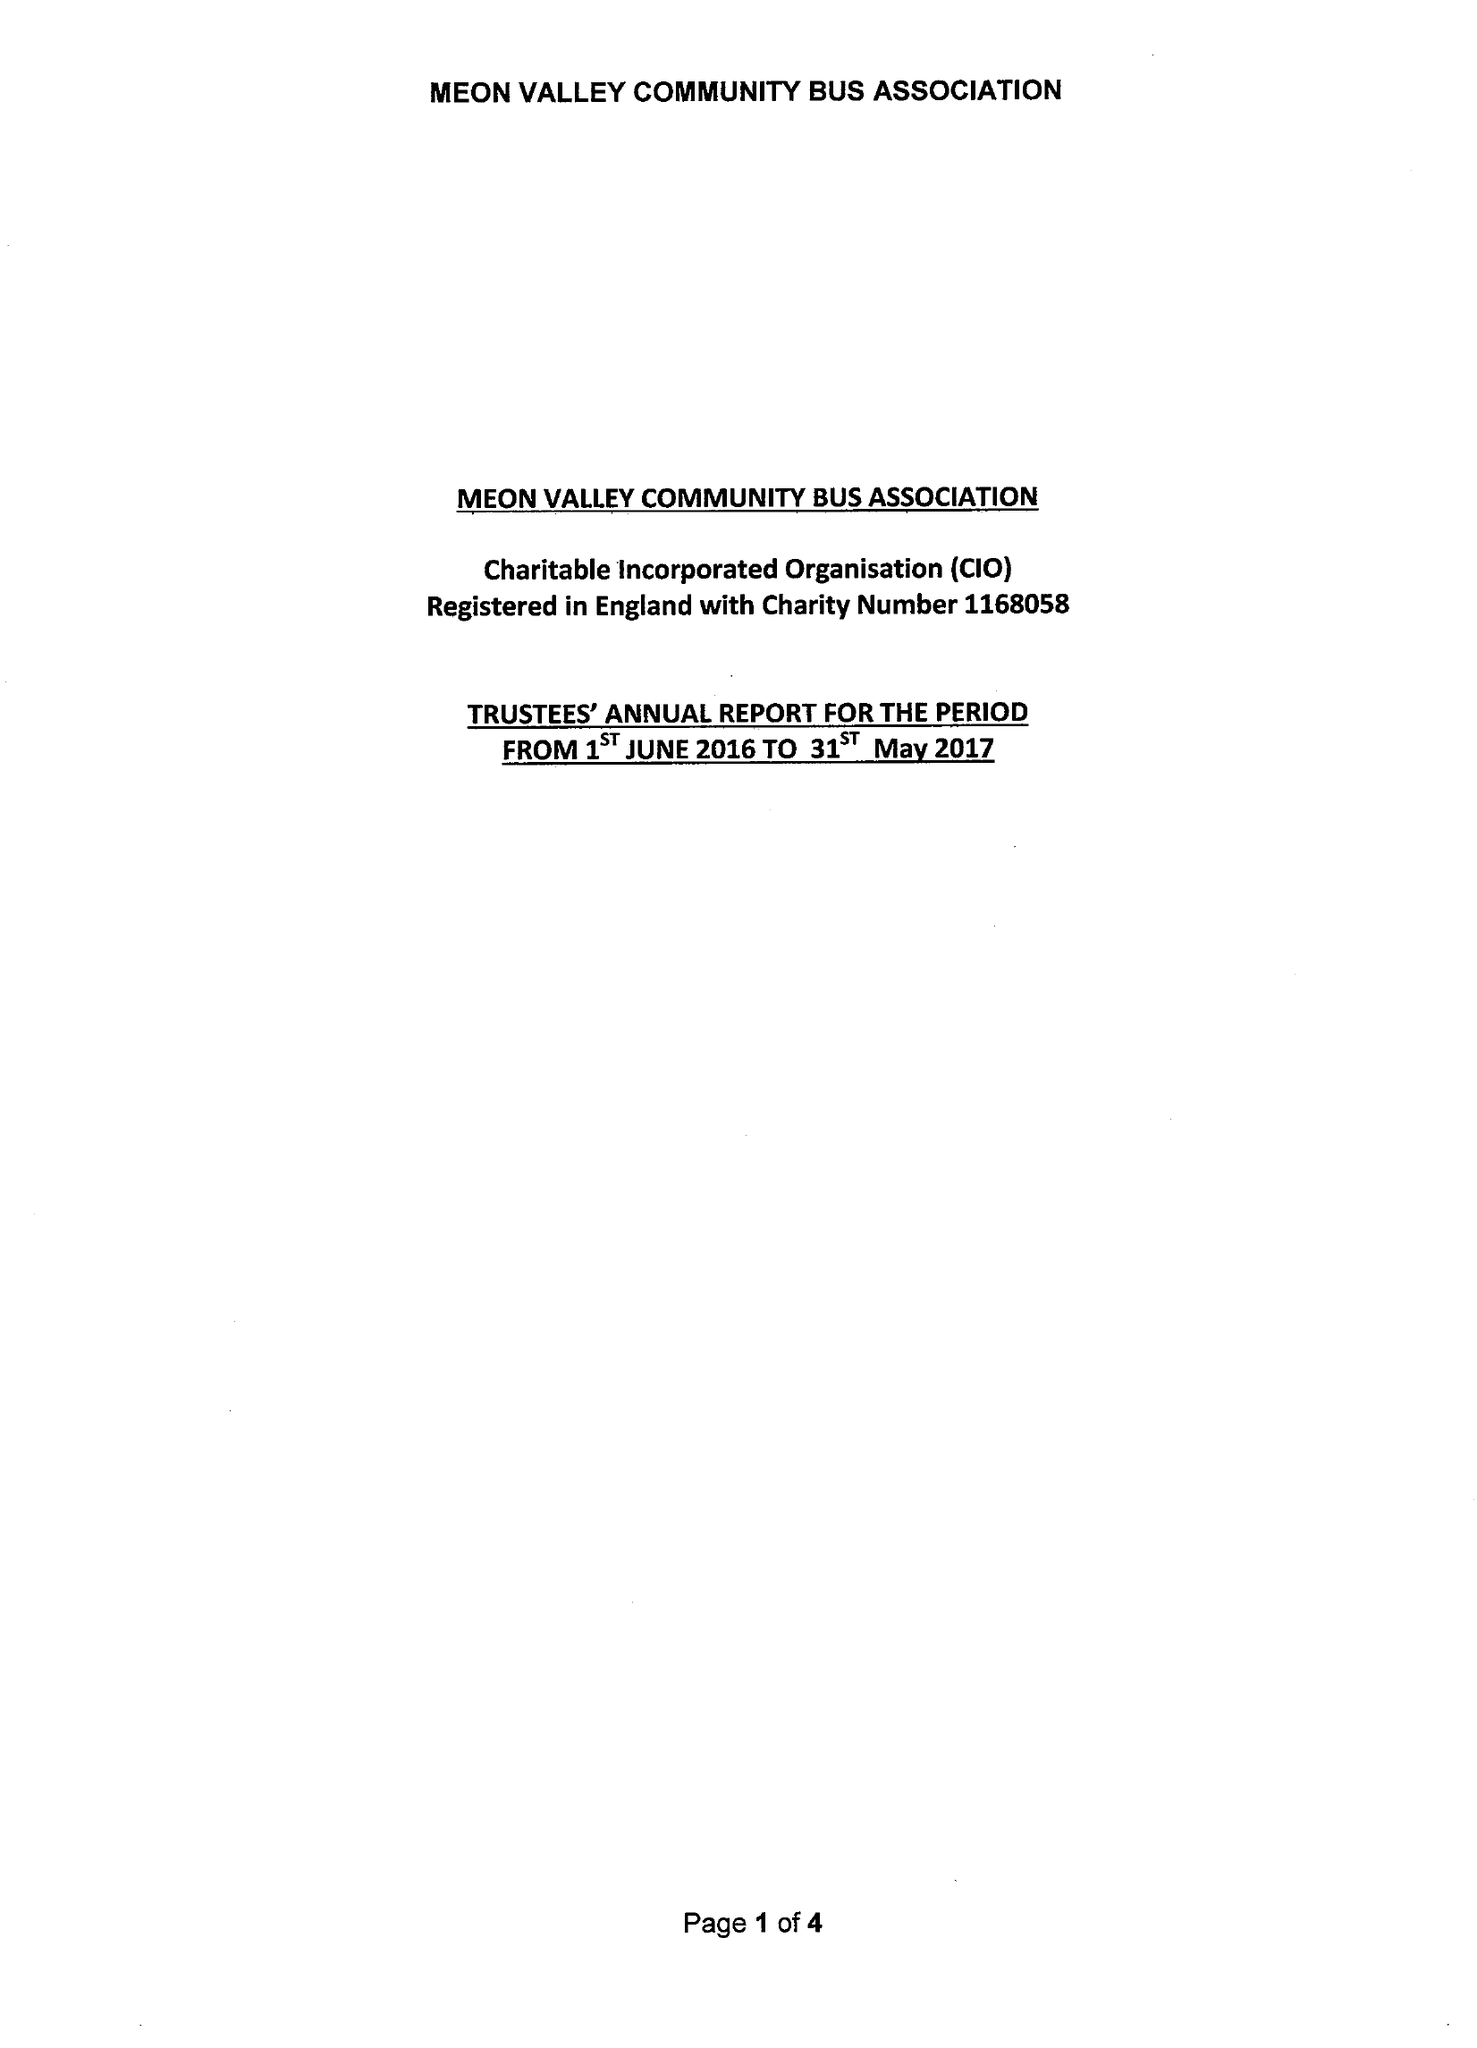What is the value for the report_date?
Answer the question using a single word or phrase. 2017-05-31 